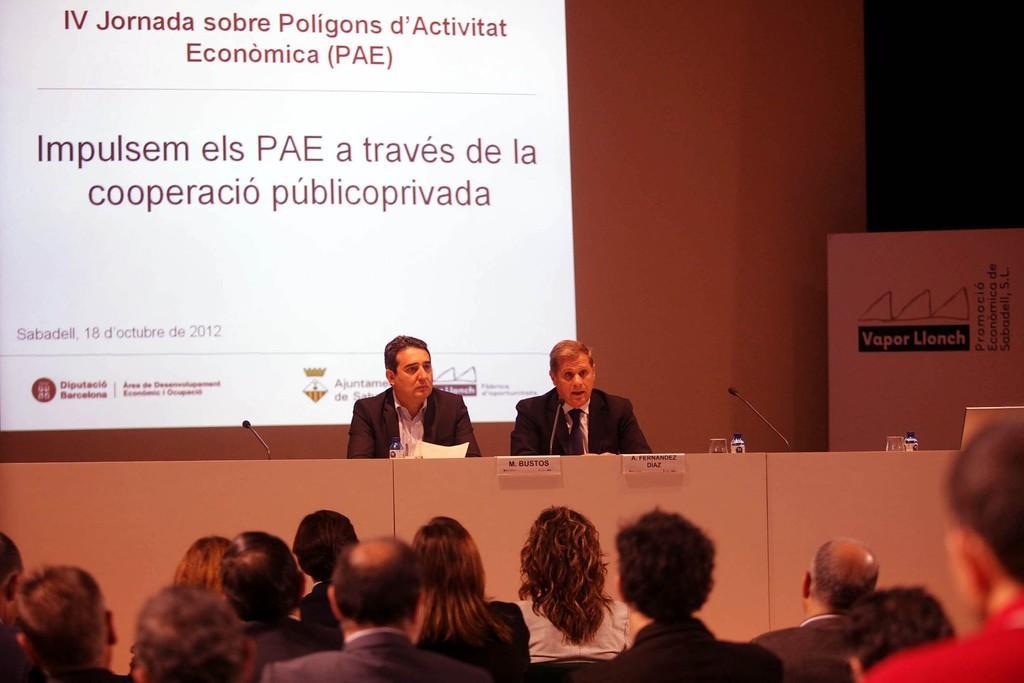How would you summarize this image in a sentence or two? In this image we can see a group of people sitting. In the center of the image we can see a person holding a paper, group of microphones, bottles, glasses and a device placed on the table. In the background, we can see a banner with some text and a screen. 